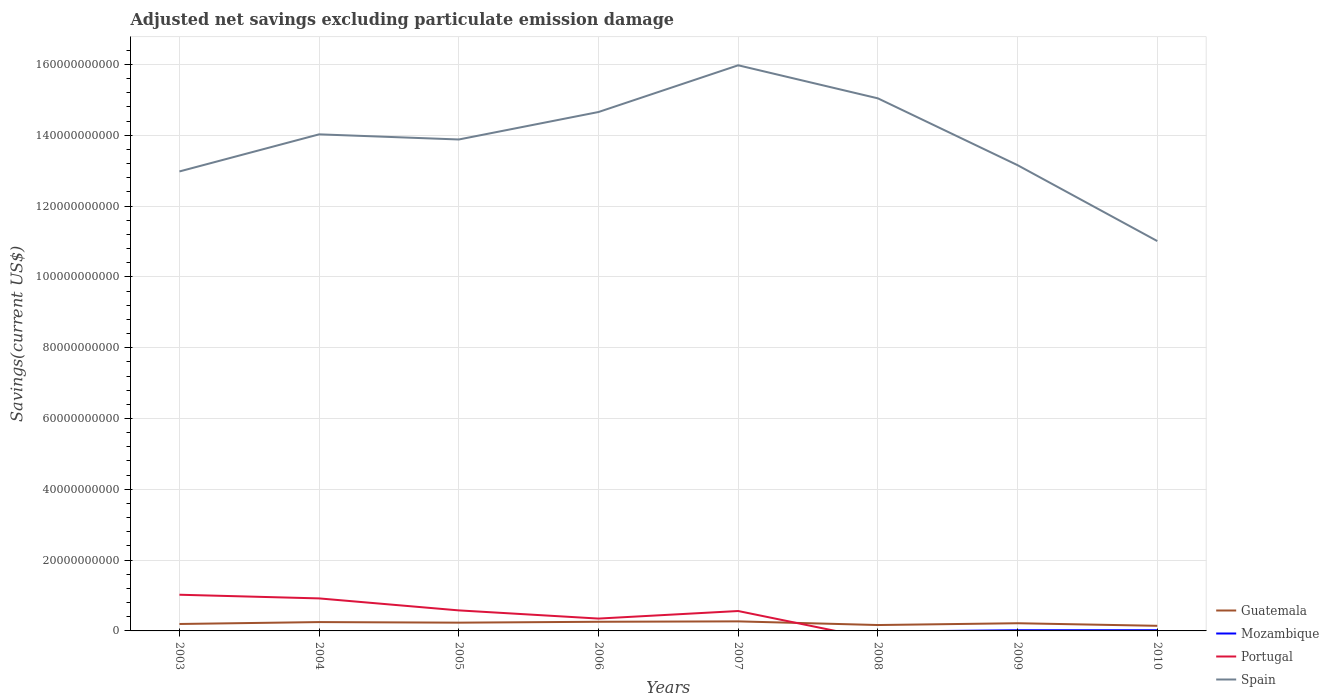Across all years, what is the maximum adjusted net savings in Spain?
Offer a very short reply. 1.10e+11. What is the total adjusted net savings in Guatemala in the graph?
Make the answer very short. 1.14e+09. What is the difference between the highest and the second highest adjusted net savings in Portugal?
Give a very brief answer. 1.02e+1. How many years are there in the graph?
Your answer should be very brief. 8. What is the difference between two consecutive major ticks on the Y-axis?
Provide a succinct answer. 2.00e+1. Does the graph contain grids?
Provide a succinct answer. Yes. Where does the legend appear in the graph?
Make the answer very short. Bottom right. How many legend labels are there?
Your response must be concise. 4. How are the legend labels stacked?
Provide a succinct answer. Vertical. What is the title of the graph?
Give a very brief answer. Adjusted net savings excluding particulate emission damage. What is the label or title of the Y-axis?
Provide a succinct answer. Savings(current US$). What is the Savings(current US$) of Guatemala in 2003?
Keep it short and to the point. 1.96e+09. What is the Savings(current US$) in Portugal in 2003?
Give a very brief answer. 1.02e+1. What is the Savings(current US$) in Spain in 2003?
Give a very brief answer. 1.30e+11. What is the Savings(current US$) in Guatemala in 2004?
Give a very brief answer. 2.50e+09. What is the Savings(current US$) of Portugal in 2004?
Offer a very short reply. 9.18e+09. What is the Savings(current US$) in Spain in 2004?
Provide a succinct answer. 1.40e+11. What is the Savings(current US$) of Guatemala in 2005?
Provide a succinct answer. 2.33e+09. What is the Savings(current US$) in Portugal in 2005?
Provide a succinct answer. 5.80e+09. What is the Savings(current US$) in Spain in 2005?
Your response must be concise. 1.39e+11. What is the Savings(current US$) in Guatemala in 2006?
Provide a short and direct response. 2.59e+09. What is the Savings(current US$) of Mozambique in 2006?
Keep it short and to the point. 0. What is the Savings(current US$) of Portugal in 2006?
Give a very brief answer. 3.49e+09. What is the Savings(current US$) of Spain in 2006?
Your answer should be compact. 1.47e+11. What is the Savings(current US$) in Guatemala in 2007?
Your answer should be very brief. 2.69e+09. What is the Savings(current US$) in Mozambique in 2007?
Offer a very short reply. 0. What is the Savings(current US$) of Portugal in 2007?
Your response must be concise. 5.62e+09. What is the Savings(current US$) of Spain in 2007?
Your response must be concise. 1.60e+11. What is the Savings(current US$) in Guatemala in 2008?
Offer a terse response. 1.66e+09. What is the Savings(current US$) in Mozambique in 2008?
Ensure brevity in your answer.  0. What is the Savings(current US$) in Portugal in 2008?
Offer a very short reply. 0. What is the Savings(current US$) in Spain in 2008?
Keep it short and to the point. 1.50e+11. What is the Savings(current US$) in Guatemala in 2009?
Provide a succinct answer. 2.17e+09. What is the Savings(current US$) in Mozambique in 2009?
Make the answer very short. 1.98e+08. What is the Savings(current US$) of Spain in 2009?
Make the answer very short. 1.32e+11. What is the Savings(current US$) in Guatemala in 2010?
Ensure brevity in your answer.  1.44e+09. What is the Savings(current US$) of Mozambique in 2010?
Make the answer very short. 2.04e+08. What is the Savings(current US$) of Spain in 2010?
Make the answer very short. 1.10e+11. Across all years, what is the maximum Savings(current US$) in Guatemala?
Your answer should be very brief. 2.69e+09. Across all years, what is the maximum Savings(current US$) in Mozambique?
Offer a very short reply. 2.04e+08. Across all years, what is the maximum Savings(current US$) of Portugal?
Provide a short and direct response. 1.02e+1. Across all years, what is the maximum Savings(current US$) of Spain?
Keep it short and to the point. 1.60e+11. Across all years, what is the minimum Savings(current US$) in Guatemala?
Keep it short and to the point. 1.44e+09. Across all years, what is the minimum Savings(current US$) of Spain?
Your answer should be very brief. 1.10e+11. What is the total Savings(current US$) of Guatemala in the graph?
Your answer should be compact. 1.73e+1. What is the total Savings(current US$) of Mozambique in the graph?
Your answer should be very brief. 4.02e+08. What is the total Savings(current US$) in Portugal in the graph?
Your response must be concise. 3.43e+1. What is the total Savings(current US$) of Spain in the graph?
Provide a succinct answer. 1.11e+12. What is the difference between the Savings(current US$) in Guatemala in 2003 and that in 2004?
Offer a very short reply. -5.36e+08. What is the difference between the Savings(current US$) in Portugal in 2003 and that in 2004?
Offer a terse response. 1.04e+09. What is the difference between the Savings(current US$) in Spain in 2003 and that in 2004?
Keep it short and to the point. -1.05e+1. What is the difference between the Savings(current US$) of Guatemala in 2003 and that in 2005?
Provide a succinct answer. -3.71e+08. What is the difference between the Savings(current US$) of Portugal in 2003 and that in 2005?
Keep it short and to the point. 4.43e+09. What is the difference between the Savings(current US$) of Spain in 2003 and that in 2005?
Keep it short and to the point. -9.03e+09. What is the difference between the Savings(current US$) of Guatemala in 2003 and that in 2006?
Offer a terse response. -6.26e+08. What is the difference between the Savings(current US$) of Portugal in 2003 and that in 2006?
Provide a succinct answer. 6.73e+09. What is the difference between the Savings(current US$) in Spain in 2003 and that in 2006?
Provide a succinct answer. -1.68e+1. What is the difference between the Savings(current US$) of Guatemala in 2003 and that in 2007?
Give a very brief answer. -7.34e+08. What is the difference between the Savings(current US$) in Portugal in 2003 and that in 2007?
Offer a terse response. 4.60e+09. What is the difference between the Savings(current US$) in Spain in 2003 and that in 2007?
Your response must be concise. -3.00e+1. What is the difference between the Savings(current US$) of Guatemala in 2003 and that in 2008?
Your response must be concise. 2.98e+08. What is the difference between the Savings(current US$) in Spain in 2003 and that in 2008?
Give a very brief answer. -2.06e+1. What is the difference between the Savings(current US$) in Guatemala in 2003 and that in 2009?
Make the answer very short. -2.08e+08. What is the difference between the Savings(current US$) of Spain in 2003 and that in 2009?
Provide a short and direct response. -1.77e+09. What is the difference between the Savings(current US$) of Guatemala in 2003 and that in 2010?
Offer a very short reply. 5.18e+08. What is the difference between the Savings(current US$) in Spain in 2003 and that in 2010?
Your answer should be compact. 1.97e+1. What is the difference between the Savings(current US$) in Guatemala in 2004 and that in 2005?
Ensure brevity in your answer.  1.65e+08. What is the difference between the Savings(current US$) in Portugal in 2004 and that in 2005?
Offer a terse response. 3.39e+09. What is the difference between the Savings(current US$) in Spain in 2004 and that in 2005?
Give a very brief answer. 1.45e+09. What is the difference between the Savings(current US$) in Guatemala in 2004 and that in 2006?
Offer a very short reply. -8.96e+07. What is the difference between the Savings(current US$) in Portugal in 2004 and that in 2006?
Give a very brief answer. 5.69e+09. What is the difference between the Savings(current US$) of Spain in 2004 and that in 2006?
Your answer should be compact. -6.31e+09. What is the difference between the Savings(current US$) of Guatemala in 2004 and that in 2007?
Keep it short and to the point. -1.97e+08. What is the difference between the Savings(current US$) of Portugal in 2004 and that in 2007?
Keep it short and to the point. 3.56e+09. What is the difference between the Savings(current US$) in Spain in 2004 and that in 2007?
Make the answer very short. -1.95e+1. What is the difference between the Savings(current US$) in Guatemala in 2004 and that in 2008?
Your answer should be compact. 8.35e+08. What is the difference between the Savings(current US$) of Spain in 2004 and that in 2008?
Provide a succinct answer. -1.02e+1. What is the difference between the Savings(current US$) in Guatemala in 2004 and that in 2009?
Give a very brief answer. 3.28e+08. What is the difference between the Savings(current US$) in Spain in 2004 and that in 2009?
Offer a very short reply. 8.71e+09. What is the difference between the Savings(current US$) in Guatemala in 2004 and that in 2010?
Your response must be concise. 1.05e+09. What is the difference between the Savings(current US$) in Spain in 2004 and that in 2010?
Ensure brevity in your answer.  3.01e+1. What is the difference between the Savings(current US$) in Guatemala in 2005 and that in 2006?
Keep it short and to the point. -2.55e+08. What is the difference between the Savings(current US$) in Portugal in 2005 and that in 2006?
Your answer should be very brief. 2.31e+09. What is the difference between the Savings(current US$) of Spain in 2005 and that in 2006?
Make the answer very short. -7.76e+09. What is the difference between the Savings(current US$) of Guatemala in 2005 and that in 2007?
Offer a very short reply. -3.62e+08. What is the difference between the Savings(current US$) of Portugal in 2005 and that in 2007?
Keep it short and to the point. 1.77e+08. What is the difference between the Savings(current US$) in Spain in 2005 and that in 2007?
Offer a terse response. -2.10e+1. What is the difference between the Savings(current US$) in Guatemala in 2005 and that in 2008?
Provide a short and direct response. 6.70e+08. What is the difference between the Savings(current US$) of Spain in 2005 and that in 2008?
Ensure brevity in your answer.  -1.16e+1. What is the difference between the Savings(current US$) of Guatemala in 2005 and that in 2009?
Keep it short and to the point. 1.63e+08. What is the difference between the Savings(current US$) in Spain in 2005 and that in 2009?
Your response must be concise. 7.26e+09. What is the difference between the Savings(current US$) of Guatemala in 2005 and that in 2010?
Offer a terse response. 8.89e+08. What is the difference between the Savings(current US$) of Spain in 2005 and that in 2010?
Offer a very short reply. 2.87e+1. What is the difference between the Savings(current US$) in Guatemala in 2006 and that in 2007?
Make the answer very short. -1.08e+08. What is the difference between the Savings(current US$) of Portugal in 2006 and that in 2007?
Provide a succinct answer. -2.13e+09. What is the difference between the Savings(current US$) in Spain in 2006 and that in 2007?
Your response must be concise. -1.32e+1. What is the difference between the Savings(current US$) in Guatemala in 2006 and that in 2008?
Ensure brevity in your answer.  9.24e+08. What is the difference between the Savings(current US$) of Spain in 2006 and that in 2008?
Keep it short and to the point. -3.86e+09. What is the difference between the Savings(current US$) in Guatemala in 2006 and that in 2009?
Keep it short and to the point. 4.18e+08. What is the difference between the Savings(current US$) of Spain in 2006 and that in 2009?
Give a very brief answer. 1.50e+1. What is the difference between the Savings(current US$) of Guatemala in 2006 and that in 2010?
Your answer should be very brief. 1.14e+09. What is the difference between the Savings(current US$) in Spain in 2006 and that in 2010?
Your answer should be very brief. 3.65e+1. What is the difference between the Savings(current US$) of Guatemala in 2007 and that in 2008?
Offer a terse response. 1.03e+09. What is the difference between the Savings(current US$) in Spain in 2007 and that in 2008?
Your answer should be very brief. 9.34e+09. What is the difference between the Savings(current US$) in Guatemala in 2007 and that in 2009?
Your response must be concise. 5.26e+08. What is the difference between the Savings(current US$) of Spain in 2007 and that in 2009?
Your answer should be compact. 2.82e+1. What is the difference between the Savings(current US$) of Guatemala in 2007 and that in 2010?
Your response must be concise. 1.25e+09. What is the difference between the Savings(current US$) in Spain in 2007 and that in 2010?
Offer a terse response. 4.96e+1. What is the difference between the Savings(current US$) of Guatemala in 2008 and that in 2009?
Offer a very short reply. -5.06e+08. What is the difference between the Savings(current US$) in Spain in 2008 and that in 2009?
Your answer should be compact. 1.89e+1. What is the difference between the Savings(current US$) of Guatemala in 2008 and that in 2010?
Provide a succinct answer. 2.19e+08. What is the difference between the Savings(current US$) of Spain in 2008 and that in 2010?
Ensure brevity in your answer.  4.03e+1. What is the difference between the Savings(current US$) in Guatemala in 2009 and that in 2010?
Your response must be concise. 7.25e+08. What is the difference between the Savings(current US$) of Mozambique in 2009 and that in 2010?
Provide a succinct answer. -6.49e+06. What is the difference between the Savings(current US$) in Spain in 2009 and that in 2010?
Keep it short and to the point. 2.14e+1. What is the difference between the Savings(current US$) of Guatemala in 2003 and the Savings(current US$) of Portugal in 2004?
Give a very brief answer. -7.22e+09. What is the difference between the Savings(current US$) of Guatemala in 2003 and the Savings(current US$) of Spain in 2004?
Provide a short and direct response. -1.38e+11. What is the difference between the Savings(current US$) in Portugal in 2003 and the Savings(current US$) in Spain in 2004?
Ensure brevity in your answer.  -1.30e+11. What is the difference between the Savings(current US$) of Guatemala in 2003 and the Savings(current US$) of Portugal in 2005?
Your answer should be very brief. -3.84e+09. What is the difference between the Savings(current US$) of Guatemala in 2003 and the Savings(current US$) of Spain in 2005?
Ensure brevity in your answer.  -1.37e+11. What is the difference between the Savings(current US$) of Portugal in 2003 and the Savings(current US$) of Spain in 2005?
Offer a very short reply. -1.29e+11. What is the difference between the Savings(current US$) of Guatemala in 2003 and the Savings(current US$) of Portugal in 2006?
Your answer should be compact. -1.53e+09. What is the difference between the Savings(current US$) of Guatemala in 2003 and the Savings(current US$) of Spain in 2006?
Offer a very short reply. -1.45e+11. What is the difference between the Savings(current US$) in Portugal in 2003 and the Savings(current US$) in Spain in 2006?
Make the answer very short. -1.36e+11. What is the difference between the Savings(current US$) in Guatemala in 2003 and the Savings(current US$) in Portugal in 2007?
Your answer should be very brief. -3.66e+09. What is the difference between the Savings(current US$) in Guatemala in 2003 and the Savings(current US$) in Spain in 2007?
Give a very brief answer. -1.58e+11. What is the difference between the Savings(current US$) of Portugal in 2003 and the Savings(current US$) of Spain in 2007?
Give a very brief answer. -1.50e+11. What is the difference between the Savings(current US$) in Guatemala in 2003 and the Savings(current US$) in Spain in 2008?
Your answer should be very brief. -1.48e+11. What is the difference between the Savings(current US$) in Portugal in 2003 and the Savings(current US$) in Spain in 2008?
Your response must be concise. -1.40e+11. What is the difference between the Savings(current US$) in Guatemala in 2003 and the Savings(current US$) in Mozambique in 2009?
Offer a terse response. 1.76e+09. What is the difference between the Savings(current US$) in Guatemala in 2003 and the Savings(current US$) in Spain in 2009?
Give a very brief answer. -1.30e+11. What is the difference between the Savings(current US$) of Portugal in 2003 and the Savings(current US$) of Spain in 2009?
Give a very brief answer. -1.21e+11. What is the difference between the Savings(current US$) in Guatemala in 2003 and the Savings(current US$) in Mozambique in 2010?
Provide a short and direct response. 1.76e+09. What is the difference between the Savings(current US$) of Guatemala in 2003 and the Savings(current US$) of Spain in 2010?
Offer a very short reply. -1.08e+11. What is the difference between the Savings(current US$) in Portugal in 2003 and the Savings(current US$) in Spain in 2010?
Offer a terse response. -9.99e+1. What is the difference between the Savings(current US$) in Guatemala in 2004 and the Savings(current US$) in Portugal in 2005?
Make the answer very short. -3.30e+09. What is the difference between the Savings(current US$) in Guatemala in 2004 and the Savings(current US$) in Spain in 2005?
Your answer should be very brief. -1.36e+11. What is the difference between the Savings(current US$) in Portugal in 2004 and the Savings(current US$) in Spain in 2005?
Your response must be concise. -1.30e+11. What is the difference between the Savings(current US$) in Guatemala in 2004 and the Savings(current US$) in Portugal in 2006?
Offer a very short reply. -9.91e+08. What is the difference between the Savings(current US$) of Guatemala in 2004 and the Savings(current US$) of Spain in 2006?
Give a very brief answer. -1.44e+11. What is the difference between the Savings(current US$) of Portugal in 2004 and the Savings(current US$) of Spain in 2006?
Provide a short and direct response. -1.37e+11. What is the difference between the Savings(current US$) of Guatemala in 2004 and the Savings(current US$) of Portugal in 2007?
Give a very brief answer. -3.12e+09. What is the difference between the Savings(current US$) of Guatemala in 2004 and the Savings(current US$) of Spain in 2007?
Offer a very short reply. -1.57e+11. What is the difference between the Savings(current US$) in Portugal in 2004 and the Savings(current US$) in Spain in 2007?
Ensure brevity in your answer.  -1.51e+11. What is the difference between the Savings(current US$) in Guatemala in 2004 and the Savings(current US$) in Spain in 2008?
Offer a terse response. -1.48e+11. What is the difference between the Savings(current US$) in Portugal in 2004 and the Savings(current US$) in Spain in 2008?
Offer a terse response. -1.41e+11. What is the difference between the Savings(current US$) in Guatemala in 2004 and the Savings(current US$) in Mozambique in 2009?
Your answer should be compact. 2.30e+09. What is the difference between the Savings(current US$) of Guatemala in 2004 and the Savings(current US$) of Spain in 2009?
Make the answer very short. -1.29e+11. What is the difference between the Savings(current US$) of Portugal in 2004 and the Savings(current US$) of Spain in 2009?
Your response must be concise. -1.22e+11. What is the difference between the Savings(current US$) of Guatemala in 2004 and the Savings(current US$) of Mozambique in 2010?
Your answer should be very brief. 2.29e+09. What is the difference between the Savings(current US$) of Guatemala in 2004 and the Savings(current US$) of Spain in 2010?
Make the answer very short. -1.08e+11. What is the difference between the Savings(current US$) in Portugal in 2004 and the Savings(current US$) in Spain in 2010?
Keep it short and to the point. -1.01e+11. What is the difference between the Savings(current US$) in Guatemala in 2005 and the Savings(current US$) in Portugal in 2006?
Ensure brevity in your answer.  -1.16e+09. What is the difference between the Savings(current US$) in Guatemala in 2005 and the Savings(current US$) in Spain in 2006?
Offer a terse response. -1.44e+11. What is the difference between the Savings(current US$) in Portugal in 2005 and the Savings(current US$) in Spain in 2006?
Make the answer very short. -1.41e+11. What is the difference between the Savings(current US$) in Guatemala in 2005 and the Savings(current US$) in Portugal in 2007?
Your answer should be very brief. -3.29e+09. What is the difference between the Savings(current US$) of Guatemala in 2005 and the Savings(current US$) of Spain in 2007?
Make the answer very short. -1.57e+11. What is the difference between the Savings(current US$) of Portugal in 2005 and the Savings(current US$) of Spain in 2007?
Give a very brief answer. -1.54e+11. What is the difference between the Savings(current US$) of Guatemala in 2005 and the Savings(current US$) of Spain in 2008?
Provide a succinct answer. -1.48e+11. What is the difference between the Savings(current US$) of Portugal in 2005 and the Savings(current US$) of Spain in 2008?
Your answer should be compact. -1.45e+11. What is the difference between the Savings(current US$) in Guatemala in 2005 and the Savings(current US$) in Mozambique in 2009?
Your answer should be compact. 2.13e+09. What is the difference between the Savings(current US$) of Guatemala in 2005 and the Savings(current US$) of Spain in 2009?
Your answer should be very brief. -1.29e+11. What is the difference between the Savings(current US$) in Portugal in 2005 and the Savings(current US$) in Spain in 2009?
Provide a short and direct response. -1.26e+11. What is the difference between the Savings(current US$) in Guatemala in 2005 and the Savings(current US$) in Mozambique in 2010?
Your answer should be compact. 2.13e+09. What is the difference between the Savings(current US$) in Guatemala in 2005 and the Savings(current US$) in Spain in 2010?
Provide a succinct answer. -1.08e+11. What is the difference between the Savings(current US$) of Portugal in 2005 and the Savings(current US$) of Spain in 2010?
Make the answer very short. -1.04e+11. What is the difference between the Savings(current US$) of Guatemala in 2006 and the Savings(current US$) of Portugal in 2007?
Provide a succinct answer. -3.03e+09. What is the difference between the Savings(current US$) of Guatemala in 2006 and the Savings(current US$) of Spain in 2007?
Ensure brevity in your answer.  -1.57e+11. What is the difference between the Savings(current US$) of Portugal in 2006 and the Savings(current US$) of Spain in 2007?
Provide a short and direct response. -1.56e+11. What is the difference between the Savings(current US$) of Guatemala in 2006 and the Savings(current US$) of Spain in 2008?
Your answer should be very brief. -1.48e+11. What is the difference between the Savings(current US$) of Portugal in 2006 and the Savings(current US$) of Spain in 2008?
Make the answer very short. -1.47e+11. What is the difference between the Savings(current US$) of Guatemala in 2006 and the Savings(current US$) of Mozambique in 2009?
Offer a terse response. 2.39e+09. What is the difference between the Savings(current US$) of Guatemala in 2006 and the Savings(current US$) of Spain in 2009?
Ensure brevity in your answer.  -1.29e+11. What is the difference between the Savings(current US$) in Portugal in 2006 and the Savings(current US$) in Spain in 2009?
Keep it short and to the point. -1.28e+11. What is the difference between the Savings(current US$) of Guatemala in 2006 and the Savings(current US$) of Mozambique in 2010?
Give a very brief answer. 2.38e+09. What is the difference between the Savings(current US$) in Guatemala in 2006 and the Savings(current US$) in Spain in 2010?
Your answer should be compact. -1.08e+11. What is the difference between the Savings(current US$) in Portugal in 2006 and the Savings(current US$) in Spain in 2010?
Your answer should be very brief. -1.07e+11. What is the difference between the Savings(current US$) in Guatemala in 2007 and the Savings(current US$) in Spain in 2008?
Keep it short and to the point. -1.48e+11. What is the difference between the Savings(current US$) in Portugal in 2007 and the Savings(current US$) in Spain in 2008?
Give a very brief answer. -1.45e+11. What is the difference between the Savings(current US$) of Guatemala in 2007 and the Savings(current US$) of Mozambique in 2009?
Give a very brief answer. 2.50e+09. What is the difference between the Savings(current US$) of Guatemala in 2007 and the Savings(current US$) of Spain in 2009?
Ensure brevity in your answer.  -1.29e+11. What is the difference between the Savings(current US$) of Portugal in 2007 and the Savings(current US$) of Spain in 2009?
Keep it short and to the point. -1.26e+11. What is the difference between the Savings(current US$) in Guatemala in 2007 and the Savings(current US$) in Mozambique in 2010?
Provide a succinct answer. 2.49e+09. What is the difference between the Savings(current US$) of Guatemala in 2007 and the Savings(current US$) of Spain in 2010?
Your answer should be very brief. -1.07e+11. What is the difference between the Savings(current US$) in Portugal in 2007 and the Savings(current US$) in Spain in 2010?
Your response must be concise. -1.04e+11. What is the difference between the Savings(current US$) of Guatemala in 2008 and the Savings(current US$) of Mozambique in 2009?
Offer a very short reply. 1.46e+09. What is the difference between the Savings(current US$) in Guatemala in 2008 and the Savings(current US$) in Spain in 2009?
Provide a succinct answer. -1.30e+11. What is the difference between the Savings(current US$) in Guatemala in 2008 and the Savings(current US$) in Mozambique in 2010?
Your response must be concise. 1.46e+09. What is the difference between the Savings(current US$) of Guatemala in 2008 and the Savings(current US$) of Spain in 2010?
Offer a terse response. -1.08e+11. What is the difference between the Savings(current US$) of Guatemala in 2009 and the Savings(current US$) of Mozambique in 2010?
Ensure brevity in your answer.  1.96e+09. What is the difference between the Savings(current US$) of Guatemala in 2009 and the Savings(current US$) of Spain in 2010?
Offer a terse response. -1.08e+11. What is the difference between the Savings(current US$) of Mozambique in 2009 and the Savings(current US$) of Spain in 2010?
Give a very brief answer. -1.10e+11. What is the average Savings(current US$) of Guatemala per year?
Give a very brief answer. 2.17e+09. What is the average Savings(current US$) in Mozambique per year?
Offer a very short reply. 5.02e+07. What is the average Savings(current US$) in Portugal per year?
Provide a succinct answer. 4.29e+09. What is the average Savings(current US$) of Spain per year?
Give a very brief answer. 1.38e+11. In the year 2003, what is the difference between the Savings(current US$) in Guatemala and Savings(current US$) in Portugal?
Offer a very short reply. -8.26e+09. In the year 2003, what is the difference between the Savings(current US$) of Guatemala and Savings(current US$) of Spain?
Keep it short and to the point. -1.28e+11. In the year 2003, what is the difference between the Savings(current US$) of Portugal and Savings(current US$) of Spain?
Your answer should be compact. -1.20e+11. In the year 2004, what is the difference between the Savings(current US$) of Guatemala and Savings(current US$) of Portugal?
Provide a short and direct response. -6.69e+09. In the year 2004, what is the difference between the Savings(current US$) of Guatemala and Savings(current US$) of Spain?
Provide a succinct answer. -1.38e+11. In the year 2004, what is the difference between the Savings(current US$) of Portugal and Savings(current US$) of Spain?
Ensure brevity in your answer.  -1.31e+11. In the year 2005, what is the difference between the Savings(current US$) in Guatemala and Savings(current US$) in Portugal?
Make the answer very short. -3.46e+09. In the year 2005, what is the difference between the Savings(current US$) in Guatemala and Savings(current US$) in Spain?
Your answer should be compact. -1.36e+11. In the year 2005, what is the difference between the Savings(current US$) in Portugal and Savings(current US$) in Spain?
Give a very brief answer. -1.33e+11. In the year 2006, what is the difference between the Savings(current US$) in Guatemala and Savings(current US$) in Portugal?
Provide a short and direct response. -9.01e+08. In the year 2006, what is the difference between the Savings(current US$) of Guatemala and Savings(current US$) of Spain?
Provide a short and direct response. -1.44e+11. In the year 2006, what is the difference between the Savings(current US$) in Portugal and Savings(current US$) in Spain?
Ensure brevity in your answer.  -1.43e+11. In the year 2007, what is the difference between the Savings(current US$) of Guatemala and Savings(current US$) of Portugal?
Your response must be concise. -2.93e+09. In the year 2007, what is the difference between the Savings(current US$) in Guatemala and Savings(current US$) in Spain?
Your answer should be very brief. -1.57e+11. In the year 2007, what is the difference between the Savings(current US$) of Portugal and Savings(current US$) of Spain?
Provide a short and direct response. -1.54e+11. In the year 2008, what is the difference between the Savings(current US$) of Guatemala and Savings(current US$) of Spain?
Make the answer very short. -1.49e+11. In the year 2009, what is the difference between the Savings(current US$) of Guatemala and Savings(current US$) of Mozambique?
Give a very brief answer. 1.97e+09. In the year 2009, what is the difference between the Savings(current US$) in Guatemala and Savings(current US$) in Spain?
Provide a succinct answer. -1.29e+11. In the year 2009, what is the difference between the Savings(current US$) of Mozambique and Savings(current US$) of Spain?
Provide a short and direct response. -1.31e+11. In the year 2010, what is the difference between the Savings(current US$) of Guatemala and Savings(current US$) of Mozambique?
Offer a terse response. 1.24e+09. In the year 2010, what is the difference between the Savings(current US$) of Guatemala and Savings(current US$) of Spain?
Your answer should be very brief. -1.09e+11. In the year 2010, what is the difference between the Savings(current US$) in Mozambique and Savings(current US$) in Spain?
Provide a short and direct response. -1.10e+11. What is the ratio of the Savings(current US$) of Guatemala in 2003 to that in 2004?
Make the answer very short. 0.79. What is the ratio of the Savings(current US$) of Portugal in 2003 to that in 2004?
Provide a succinct answer. 1.11. What is the ratio of the Savings(current US$) in Spain in 2003 to that in 2004?
Provide a succinct answer. 0.93. What is the ratio of the Savings(current US$) in Guatemala in 2003 to that in 2005?
Provide a short and direct response. 0.84. What is the ratio of the Savings(current US$) in Portugal in 2003 to that in 2005?
Your response must be concise. 1.76. What is the ratio of the Savings(current US$) in Spain in 2003 to that in 2005?
Give a very brief answer. 0.94. What is the ratio of the Savings(current US$) of Guatemala in 2003 to that in 2006?
Ensure brevity in your answer.  0.76. What is the ratio of the Savings(current US$) in Portugal in 2003 to that in 2006?
Ensure brevity in your answer.  2.93. What is the ratio of the Savings(current US$) of Spain in 2003 to that in 2006?
Offer a very short reply. 0.89. What is the ratio of the Savings(current US$) in Guatemala in 2003 to that in 2007?
Give a very brief answer. 0.73. What is the ratio of the Savings(current US$) of Portugal in 2003 to that in 2007?
Your response must be concise. 1.82. What is the ratio of the Savings(current US$) of Spain in 2003 to that in 2007?
Give a very brief answer. 0.81. What is the ratio of the Savings(current US$) in Guatemala in 2003 to that in 2008?
Offer a terse response. 1.18. What is the ratio of the Savings(current US$) of Spain in 2003 to that in 2008?
Your answer should be very brief. 0.86. What is the ratio of the Savings(current US$) in Guatemala in 2003 to that in 2009?
Your answer should be compact. 0.9. What is the ratio of the Savings(current US$) of Spain in 2003 to that in 2009?
Offer a terse response. 0.99. What is the ratio of the Savings(current US$) of Guatemala in 2003 to that in 2010?
Provide a short and direct response. 1.36. What is the ratio of the Savings(current US$) in Spain in 2003 to that in 2010?
Give a very brief answer. 1.18. What is the ratio of the Savings(current US$) in Guatemala in 2004 to that in 2005?
Give a very brief answer. 1.07. What is the ratio of the Savings(current US$) in Portugal in 2004 to that in 2005?
Give a very brief answer. 1.58. What is the ratio of the Savings(current US$) of Spain in 2004 to that in 2005?
Your response must be concise. 1.01. What is the ratio of the Savings(current US$) in Guatemala in 2004 to that in 2006?
Give a very brief answer. 0.97. What is the ratio of the Savings(current US$) of Portugal in 2004 to that in 2006?
Keep it short and to the point. 2.63. What is the ratio of the Savings(current US$) of Spain in 2004 to that in 2006?
Ensure brevity in your answer.  0.96. What is the ratio of the Savings(current US$) in Guatemala in 2004 to that in 2007?
Keep it short and to the point. 0.93. What is the ratio of the Savings(current US$) in Portugal in 2004 to that in 2007?
Your answer should be compact. 1.63. What is the ratio of the Savings(current US$) in Spain in 2004 to that in 2007?
Offer a very short reply. 0.88. What is the ratio of the Savings(current US$) of Guatemala in 2004 to that in 2008?
Give a very brief answer. 1.5. What is the ratio of the Savings(current US$) in Spain in 2004 to that in 2008?
Provide a short and direct response. 0.93. What is the ratio of the Savings(current US$) of Guatemala in 2004 to that in 2009?
Offer a terse response. 1.15. What is the ratio of the Savings(current US$) of Spain in 2004 to that in 2009?
Provide a succinct answer. 1.07. What is the ratio of the Savings(current US$) in Guatemala in 2004 to that in 2010?
Offer a terse response. 1.73. What is the ratio of the Savings(current US$) in Spain in 2004 to that in 2010?
Provide a short and direct response. 1.27. What is the ratio of the Savings(current US$) of Guatemala in 2005 to that in 2006?
Keep it short and to the point. 0.9. What is the ratio of the Savings(current US$) of Portugal in 2005 to that in 2006?
Offer a very short reply. 1.66. What is the ratio of the Savings(current US$) in Spain in 2005 to that in 2006?
Ensure brevity in your answer.  0.95. What is the ratio of the Savings(current US$) of Guatemala in 2005 to that in 2007?
Ensure brevity in your answer.  0.87. What is the ratio of the Savings(current US$) of Portugal in 2005 to that in 2007?
Your response must be concise. 1.03. What is the ratio of the Savings(current US$) of Spain in 2005 to that in 2007?
Provide a succinct answer. 0.87. What is the ratio of the Savings(current US$) in Guatemala in 2005 to that in 2008?
Provide a succinct answer. 1.4. What is the ratio of the Savings(current US$) of Spain in 2005 to that in 2008?
Provide a short and direct response. 0.92. What is the ratio of the Savings(current US$) in Guatemala in 2005 to that in 2009?
Your answer should be compact. 1.08. What is the ratio of the Savings(current US$) in Spain in 2005 to that in 2009?
Make the answer very short. 1.06. What is the ratio of the Savings(current US$) of Guatemala in 2005 to that in 2010?
Your answer should be very brief. 1.62. What is the ratio of the Savings(current US$) of Spain in 2005 to that in 2010?
Provide a succinct answer. 1.26. What is the ratio of the Savings(current US$) of Guatemala in 2006 to that in 2007?
Provide a succinct answer. 0.96. What is the ratio of the Savings(current US$) in Portugal in 2006 to that in 2007?
Offer a terse response. 0.62. What is the ratio of the Savings(current US$) in Spain in 2006 to that in 2007?
Provide a short and direct response. 0.92. What is the ratio of the Savings(current US$) of Guatemala in 2006 to that in 2008?
Ensure brevity in your answer.  1.56. What is the ratio of the Savings(current US$) of Spain in 2006 to that in 2008?
Your answer should be very brief. 0.97. What is the ratio of the Savings(current US$) in Guatemala in 2006 to that in 2009?
Your answer should be very brief. 1.19. What is the ratio of the Savings(current US$) in Spain in 2006 to that in 2009?
Give a very brief answer. 1.11. What is the ratio of the Savings(current US$) of Guatemala in 2006 to that in 2010?
Offer a very short reply. 1.79. What is the ratio of the Savings(current US$) of Spain in 2006 to that in 2010?
Ensure brevity in your answer.  1.33. What is the ratio of the Savings(current US$) of Guatemala in 2007 to that in 2008?
Provide a short and direct response. 1.62. What is the ratio of the Savings(current US$) in Spain in 2007 to that in 2008?
Offer a terse response. 1.06. What is the ratio of the Savings(current US$) of Guatemala in 2007 to that in 2009?
Your answer should be compact. 1.24. What is the ratio of the Savings(current US$) in Spain in 2007 to that in 2009?
Offer a terse response. 1.21. What is the ratio of the Savings(current US$) of Guatemala in 2007 to that in 2010?
Ensure brevity in your answer.  1.87. What is the ratio of the Savings(current US$) of Spain in 2007 to that in 2010?
Keep it short and to the point. 1.45. What is the ratio of the Savings(current US$) of Guatemala in 2008 to that in 2009?
Give a very brief answer. 0.77. What is the ratio of the Savings(current US$) of Spain in 2008 to that in 2009?
Offer a terse response. 1.14. What is the ratio of the Savings(current US$) in Guatemala in 2008 to that in 2010?
Your answer should be compact. 1.15. What is the ratio of the Savings(current US$) in Spain in 2008 to that in 2010?
Keep it short and to the point. 1.37. What is the ratio of the Savings(current US$) of Guatemala in 2009 to that in 2010?
Give a very brief answer. 1.5. What is the ratio of the Savings(current US$) in Mozambique in 2009 to that in 2010?
Your answer should be compact. 0.97. What is the ratio of the Savings(current US$) in Spain in 2009 to that in 2010?
Make the answer very short. 1.19. What is the difference between the highest and the second highest Savings(current US$) in Guatemala?
Provide a succinct answer. 1.08e+08. What is the difference between the highest and the second highest Savings(current US$) in Portugal?
Give a very brief answer. 1.04e+09. What is the difference between the highest and the second highest Savings(current US$) in Spain?
Make the answer very short. 9.34e+09. What is the difference between the highest and the lowest Savings(current US$) in Guatemala?
Make the answer very short. 1.25e+09. What is the difference between the highest and the lowest Savings(current US$) of Mozambique?
Your answer should be very brief. 2.04e+08. What is the difference between the highest and the lowest Savings(current US$) of Portugal?
Your answer should be very brief. 1.02e+1. What is the difference between the highest and the lowest Savings(current US$) of Spain?
Your answer should be compact. 4.96e+1. 